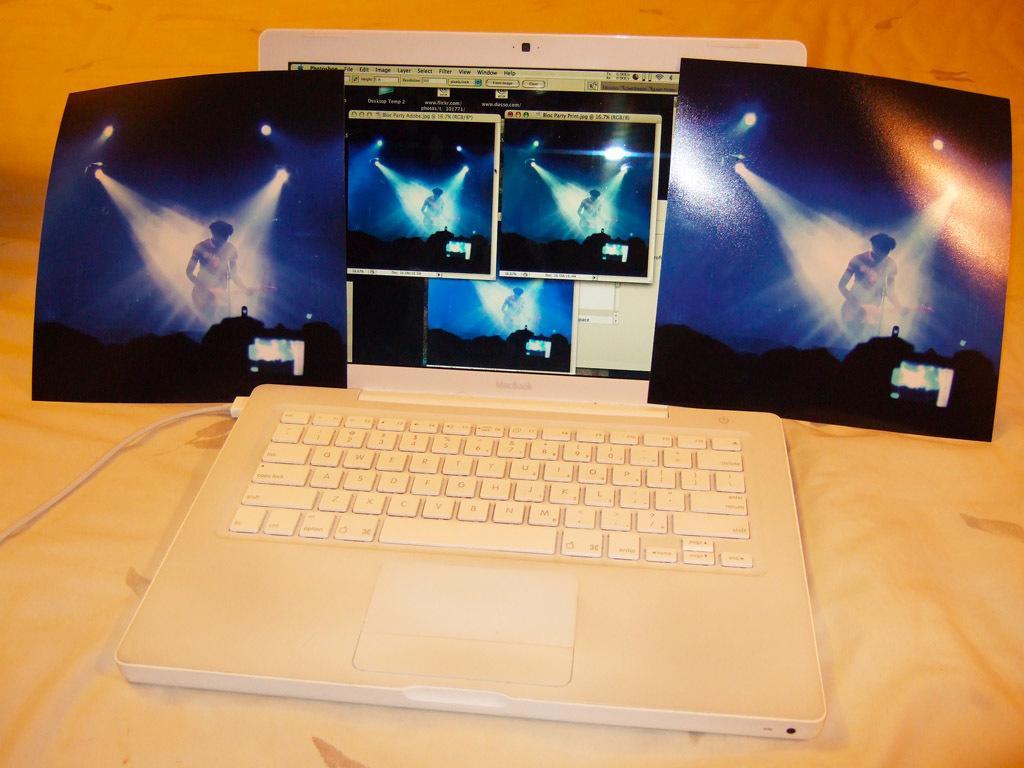Could you give a brief overview of what you see in this image? In the center of the image we can see a laptop and pictures placed on the cloth. 